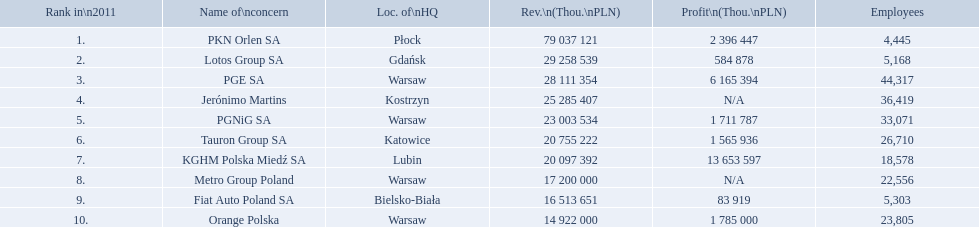What companies are listed? PKN Orlen SA, Lotos Group SA, PGE SA, Jerónimo Martins, PGNiG SA, Tauron Group SA, KGHM Polska Miedź SA, Metro Group Poland, Fiat Auto Poland SA, Orange Polska. What are the company's revenues? 79 037 121, 29 258 539, 28 111 354, 25 285 407, 23 003 534, 20 755 222, 20 097 392, 17 200 000, 16 513 651, 14 922 000. Which company has the greatest revenue? PKN Orlen SA. What are the names of all the concerns? PKN Orlen SA, Lotos Group SA, PGE SA, Jerónimo Martins, PGNiG SA, Tauron Group SA, KGHM Polska Miedź SA, Metro Group Poland, Fiat Auto Poland SA, Orange Polska. How many employees does pgnig sa have? 33,071. 